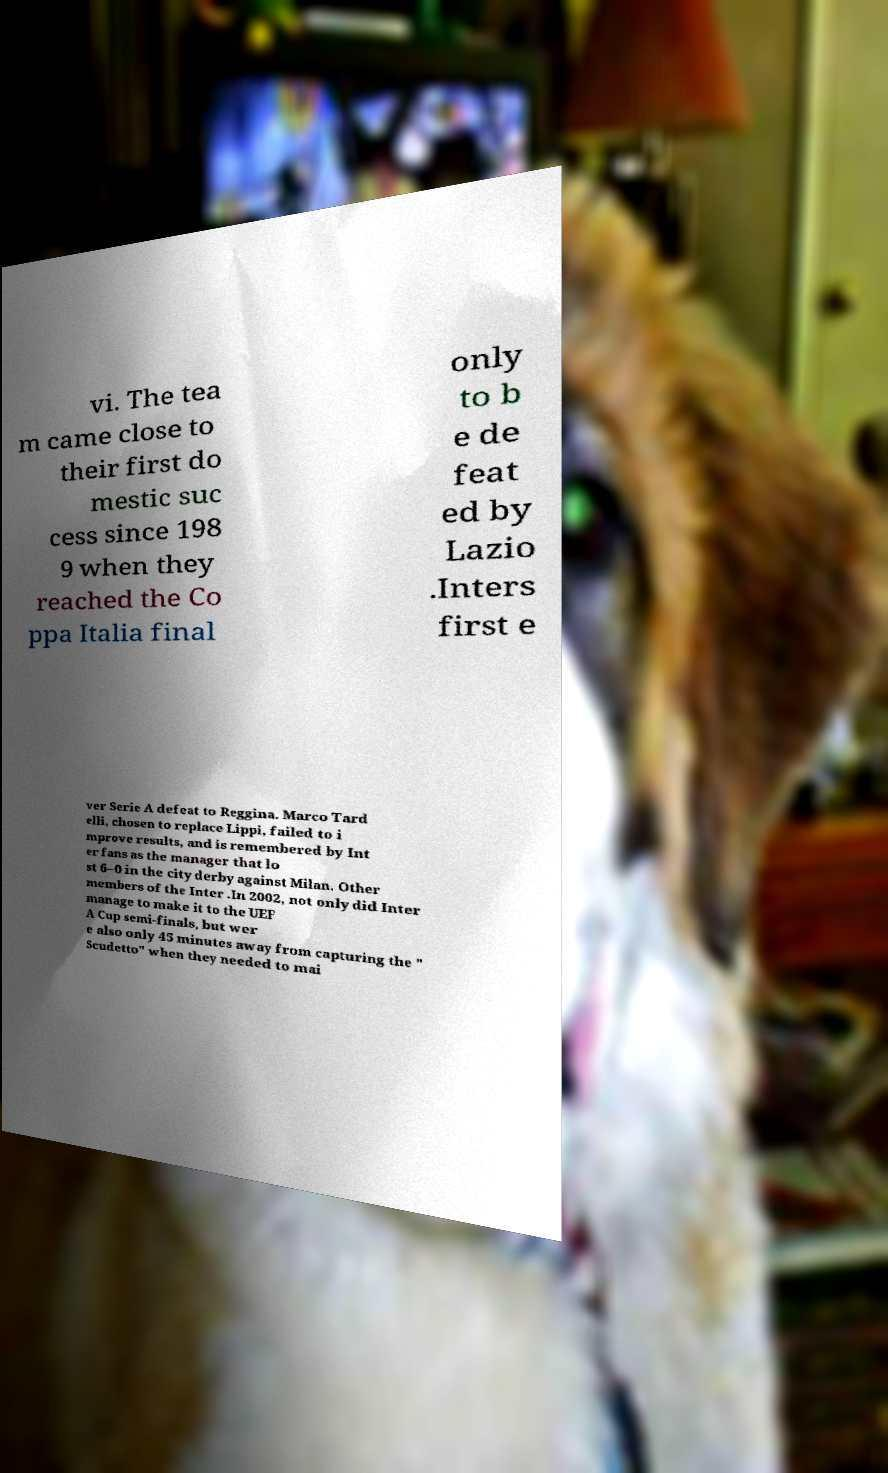Please identify and transcribe the text found in this image. vi. The tea m came close to their first do mestic suc cess since 198 9 when they reached the Co ppa Italia final only to b e de feat ed by Lazio .Inters first e ver Serie A defeat to Reggina. Marco Tard elli, chosen to replace Lippi, failed to i mprove results, and is remembered by Int er fans as the manager that lo st 6–0 in the city derby against Milan. Other members of the Inter .In 2002, not only did Inter manage to make it to the UEF A Cup semi-finals, but wer e also only 45 minutes away from capturing the " Scudetto" when they needed to mai 